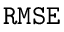<formula> <loc_0><loc_0><loc_500><loc_500>R M S E</formula> 